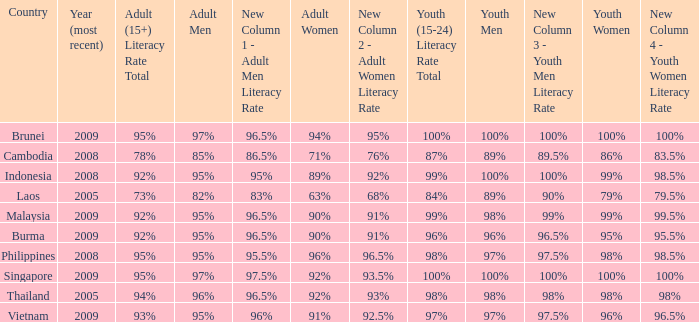Which country has its most recent year as being 2005 and has an Adult Men literacy rate of 96%? Thailand. 